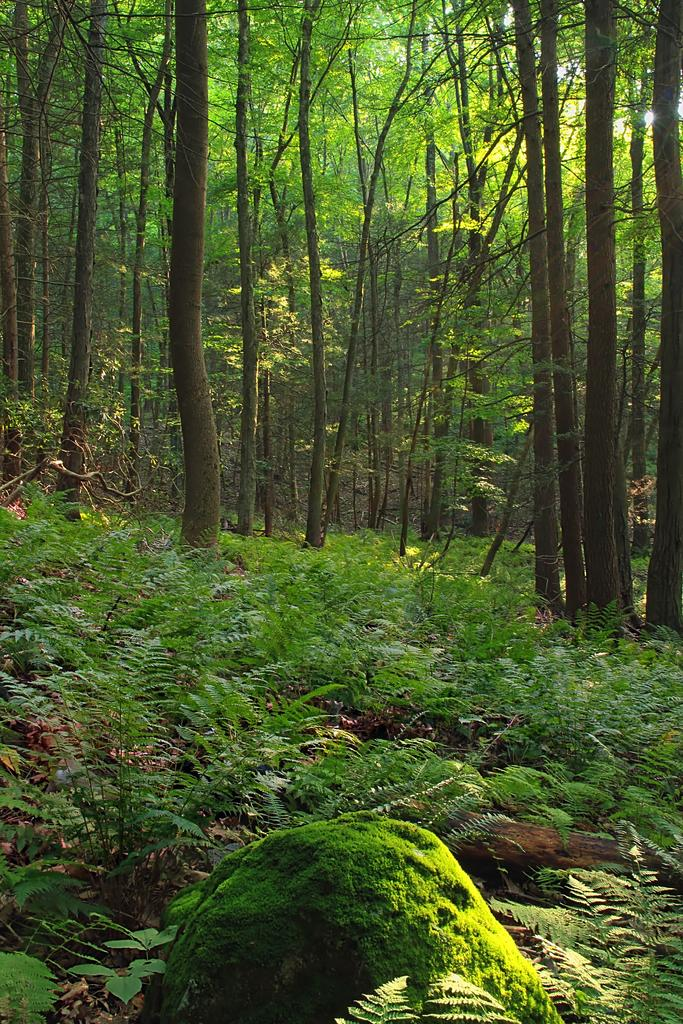What type of environment might the image be taken in? The image might be taken in a forest. What can be seen in the foreground of the image? There are plants and dry leaves in the foreground of the image. What is visible in the background of the image? There are trees in the background of the image. What shape is the woman holding in the image? There is no woman or shape present in the image; it features plants and trees in a forest setting. 